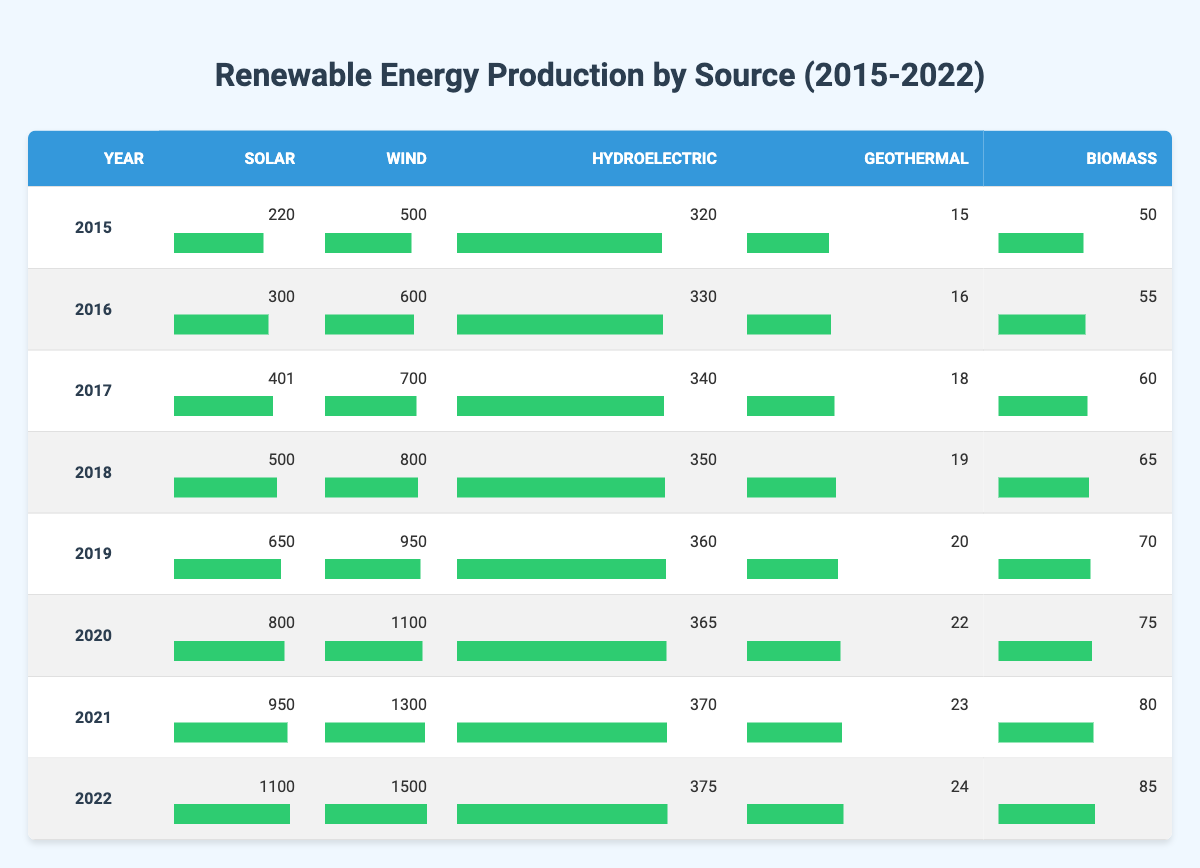What is the solar energy production in 2022? In 2022, the table shows that the solar energy production is 1100.
Answer: 1100 Which year had the highest wind energy production? By looking through the table, it can be seen that the wind energy production is highest in 2022 at 1500.
Answer: 2022 What is the average hydroelectric production from 2015 to 2022? To find the average hydroelectric production, we sum the values for each year: 320 + 330 + 340 + 350 + 360 + 365 + 370 + 375 = 3210. Since there are 8 years, the average is 3210/8 = 401.25.
Answer: 401.25 Was there an increase in geothermal energy production from 2015 to 2020? In 2015, geothermal energy production was 15, and in 2020, it was 22. Since 22 is greater than 15, there was an increase.
Answer: Yes What is the difference in biomass energy production between 2015 and 2022? The biomass production in 2015 was 50, and in 2022, it was 85. The difference is 85 - 50 = 35.
Answer: 35 Which renewable energy source had the least production in 2019? In 2019, geothermal energy production was the least at 20, compared to solar (650), wind (950), hydroelectric (360), and biomass (70).
Answer: Geothermal What is the total renewable energy production across all sources in 2021? To find the total production in 2021, we add all energy sources together: 950 + 1300 + 370 + 23 + 80 = 3023.
Answer: 3023 In which year was the biomass production 70? Referring to the table, biomass production was 70 in 2019.
Answer: 2019 Did hydroelectric production increase every year from 2015 to 2022? By comparing the hydroelectric production for each year, it can be observed that it increased from 320 in 2015 to 375 in 2022, indicating an increase every year.
Answer: Yes 